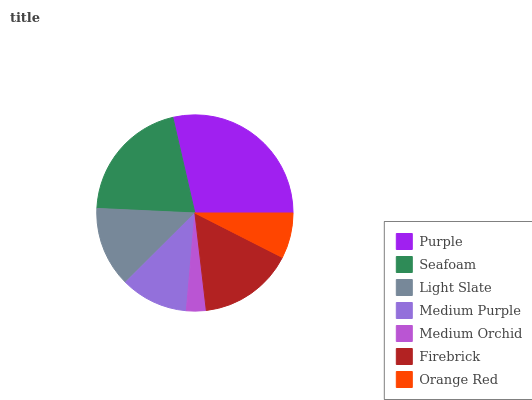Is Medium Orchid the minimum?
Answer yes or no. Yes. Is Purple the maximum?
Answer yes or no. Yes. Is Seafoam the minimum?
Answer yes or no. No. Is Seafoam the maximum?
Answer yes or no. No. Is Purple greater than Seafoam?
Answer yes or no. Yes. Is Seafoam less than Purple?
Answer yes or no. Yes. Is Seafoam greater than Purple?
Answer yes or no. No. Is Purple less than Seafoam?
Answer yes or no. No. Is Light Slate the high median?
Answer yes or no. Yes. Is Light Slate the low median?
Answer yes or no. Yes. Is Purple the high median?
Answer yes or no. No. Is Medium Purple the low median?
Answer yes or no. No. 